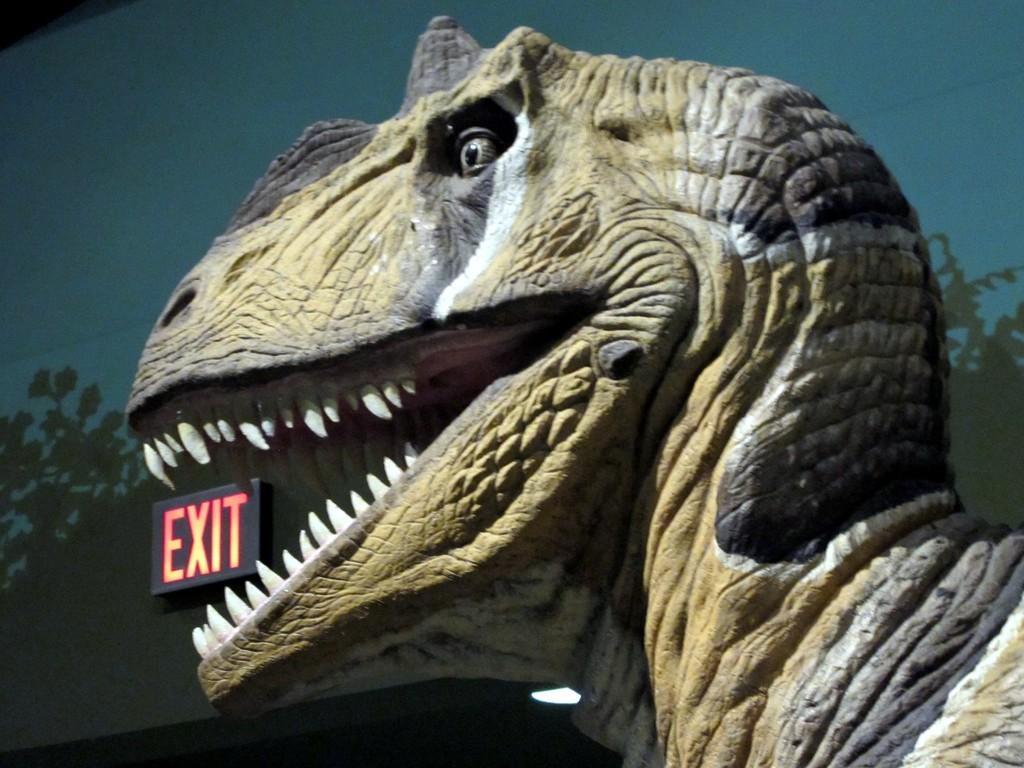Describe this image in one or two sentences. In this picture we can observe a statue of a dinosaur. This is brown and black color. We can observe an exit board fixed to the wall. In the background there is a wall. 